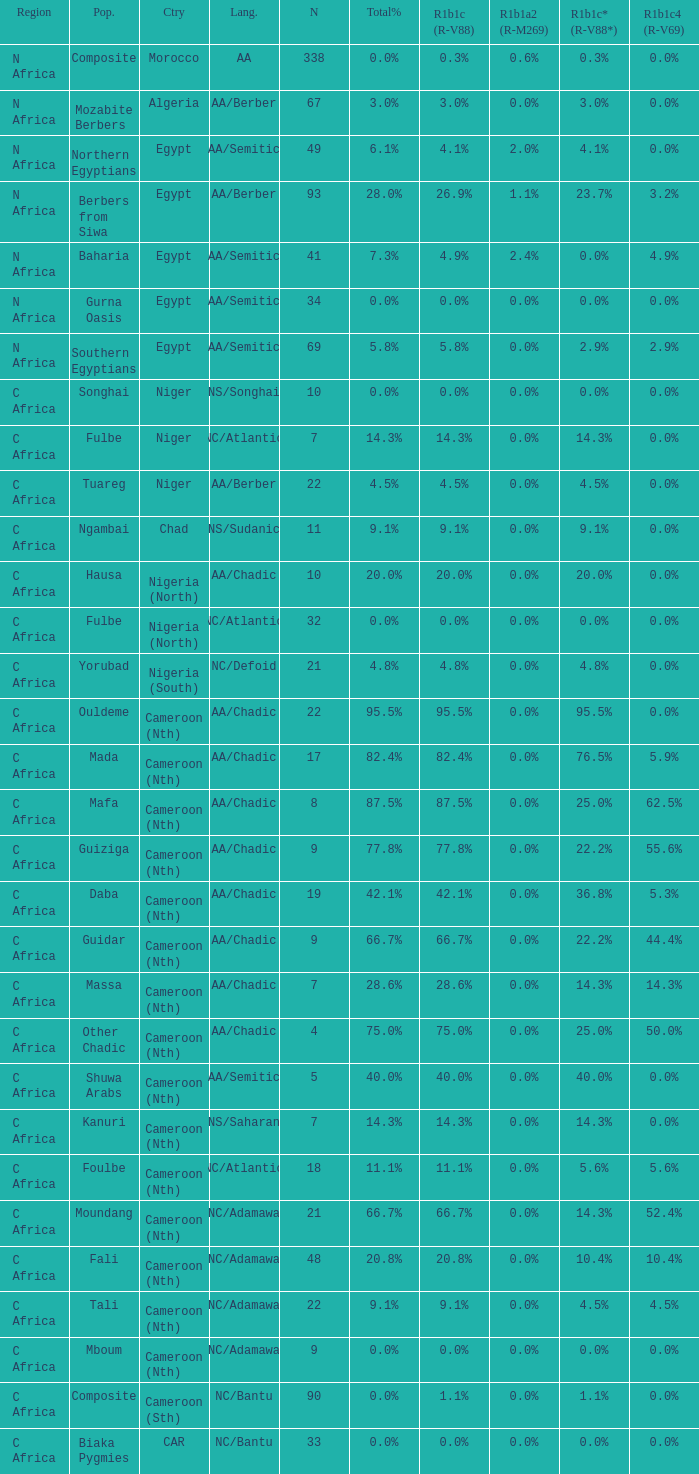What percentage is listed in column r1b1c (r-v88) for the 4.5% total percentage? 4.5%. 